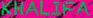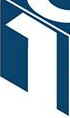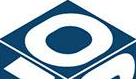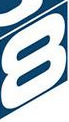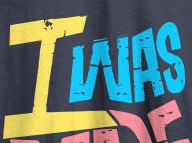Read the text content from these images in order, separated by a semicolon. KHALIFA; 1; 0; 8; IWAS 